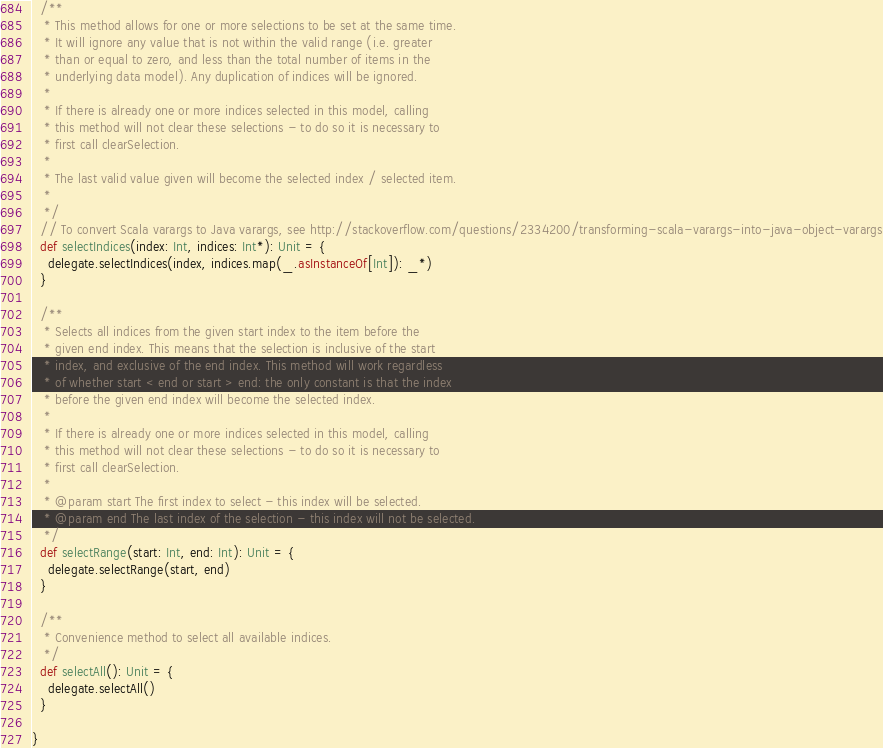Convert code to text. <code><loc_0><loc_0><loc_500><loc_500><_Scala_>  /**
   * This method allows for one or more selections to be set at the same time. 
   * It will ignore any value that is not within the valid range (i.e. greater 
   * than or equal to zero, and less than the total number of items in the 
   * underlying data model). Any duplication of indices will be ignored.
   *
   * If there is already one or more indices selected in this model, calling 
   * this method will not clear these selections - to do so it is necessary to 
   * first call clearSelection.
   *
   * The last valid value given will become the selected index / selected item.
   *
   */
  // To convert Scala varargs to Java varargs, see http://stackoverflow.com/questions/2334200/transforming-scala-varargs-into-java-object-varargs
  def selectIndices(index: Int, indices: Int*): Unit = {
    delegate.selectIndices(index, indices.map(_.asInstanceOf[Int]): _*)
  }

  /**
   * Selects all indices from the given start index to the item before the 
   * given end index. This means that the selection is inclusive of the start 
   * index, and exclusive of the end index. This method will work regardless 
   * of whether start < end or start > end: the only constant is that the index 
   * before the given end index will become the selected index.
   *
   * If there is already one or more indices selected in this model, calling 
   * this method will not clear these selections - to do so it is necessary to 
   * first call clearSelection.
   *
   * @param start The first index to select - this index will be selected.
   * @param end The last index of the selection - this index will not be selected.
   */
  def selectRange(start: Int, end: Int): Unit = {
    delegate.selectRange(start, end)
  }

  /**
   * Convenience method to select all available indices.
   */
  def selectAll(): Unit = {
    delegate.selectAll()
  }

}
</code> 